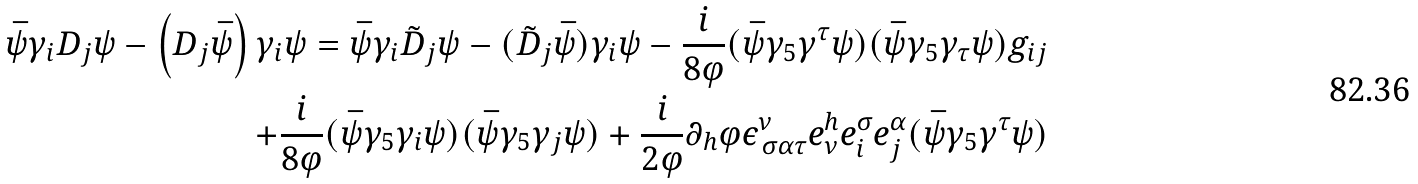Convert formula to latex. <formula><loc_0><loc_0><loc_500><loc_500>\bar { \psi } \gamma _ { i } D _ { j } \psi - \left ( D _ { j } \bar { \psi } \right ) \gamma _ { i } \psi = \bar { \psi } \gamma _ { i } \tilde { D } _ { j } \psi - ( \tilde { D } _ { j } \bar { \psi } ) \gamma _ { i } \psi - \frac { i } { 8 \varphi } ( \bar { \psi } \gamma _ { 5 } \gamma ^ { \tau } \psi ) ( \bar { \psi } \gamma _ { 5 } \gamma _ { \tau } \psi ) g _ { i j } \\ + \frac { i } { 8 \varphi } ( \bar { \psi } \gamma _ { 5 } \gamma _ { i } \psi ) ( \bar { \psi } \gamma _ { 5 } \gamma _ { j } \psi ) + \frac { i } { 2 \varphi } \partial _ { h } \varphi \epsilon ^ { \nu } _ { \, \sigma \alpha \tau } e ^ { h } _ { \nu } \/ e ^ { \sigma } _ { i } \/ e ^ { \alpha } _ { j } ( \bar { \psi } \gamma _ { 5 } \gamma ^ { \tau } \psi )</formula> 